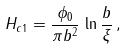Convert formula to latex. <formula><loc_0><loc_0><loc_500><loc_500>H _ { c 1 } = \frac { \phi _ { 0 } } { \pi b ^ { 2 } } \, \ln \frac { b } { \xi } \, ,</formula> 